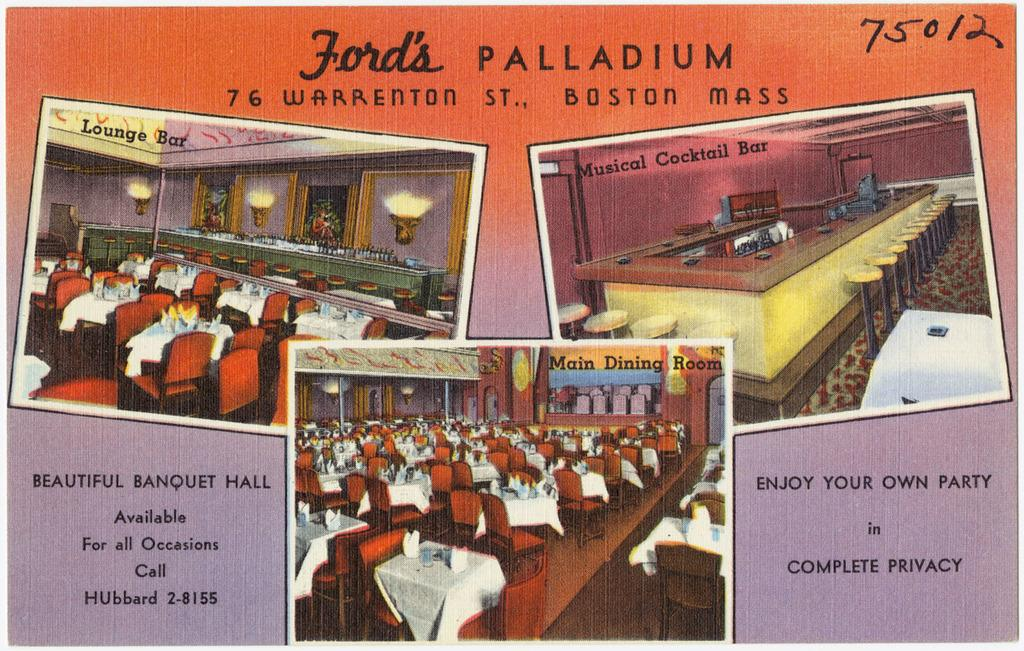What is present on the poster in the image? There is a poster in the image that contains text and images. What type of content is included in the images on the poster? The images on the poster depict an inside view. Can you tell me how many beetles are crawling on the poster in the image? There are no beetles present on the poster in the image. 